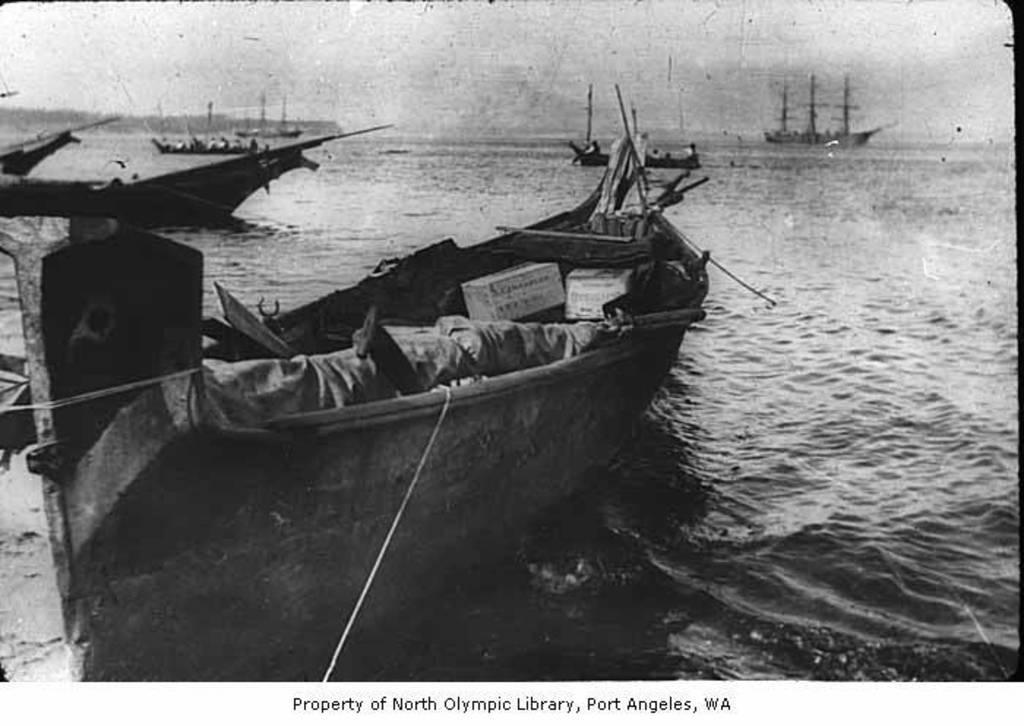What is the color scheme of the image? The image is black and white. What can be seen on the surface of the river in the image? There are boats on the surface of the river in the image. What part of the natural environment is visible in the image? The sky is visible in the image. What is present at the bottom of the image? There is text at the bottom of the image. How does the dust affect the visibility of the boats in the image? There is no dust present in the image, so it does not affect the visibility of the boats. What is the starting point for the boats in the image? The image does not show the starting point for the boats; it only shows them on the surface of the river. 